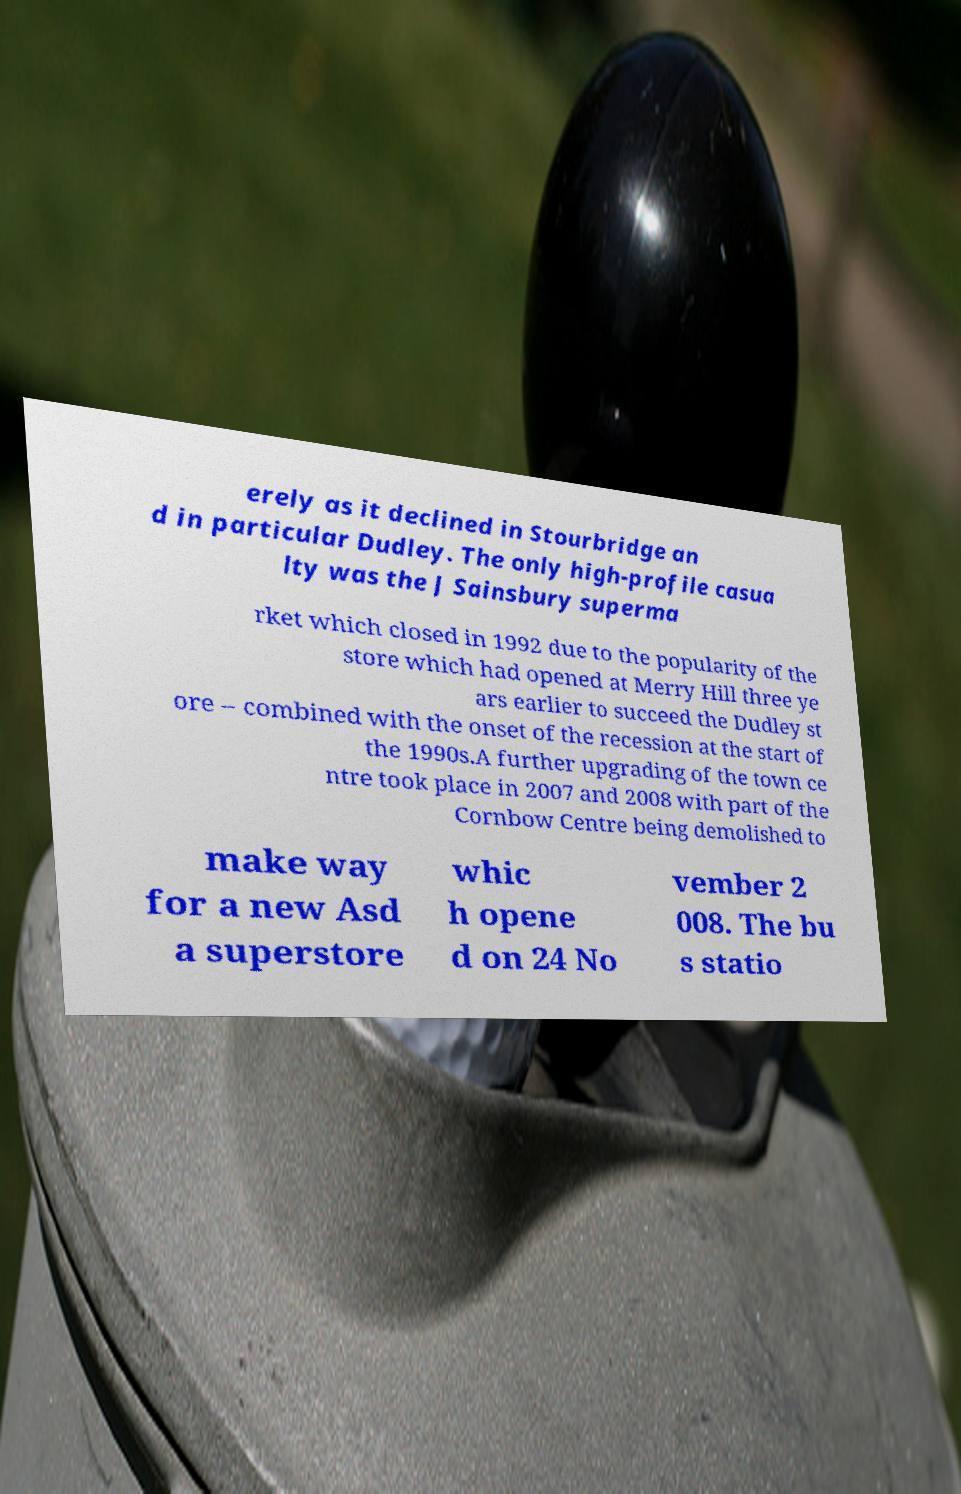I need the written content from this picture converted into text. Can you do that? erely as it declined in Stourbridge an d in particular Dudley. The only high-profile casua lty was the J Sainsbury superma rket which closed in 1992 due to the popularity of the store which had opened at Merry Hill three ye ars earlier to succeed the Dudley st ore – combined with the onset of the recession at the start of the 1990s.A further upgrading of the town ce ntre took place in 2007 and 2008 with part of the Cornbow Centre being demolished to make way for a new Asd a superstore whic h opene d on 24 No vember 2 008. The bu s statio 